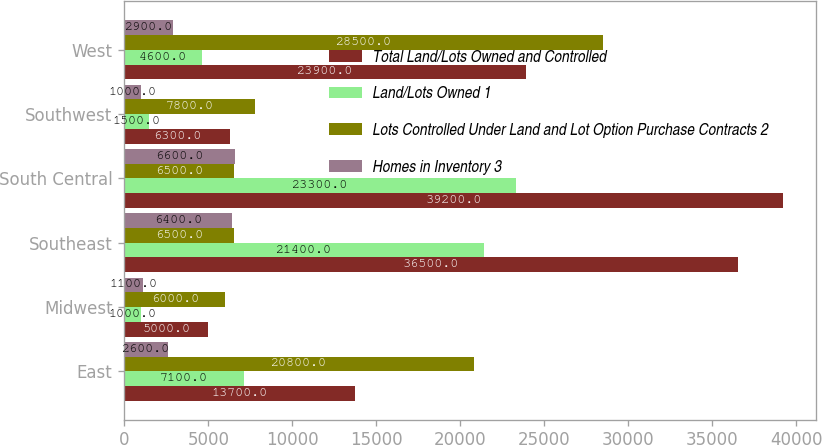Convert chart to OTSL. <chart><loc_0><loc_0><loc_500><loc_500><stacked_bar_chart><ecel><fcel>East<fcel>Midwest<fcel>Southeast<fcel>South Central<fcel>Southwest<fcel>West<nl><fcel>Total Land/Lots Owned and Controlled<fcel>13700<fcel>5000<fcel>36500<fcel>39200<fcel>6300<fcel>23900<nl><fcel>Land/Lots Owned 1<fcel>7100<fcel>1000<fcel>21400<fcel>23300<fcel>1500<fcel>4600<nl><fcel>Lots Controlled Under Land and Lot Option Purchase Contracts 2<fcel>20800<fcel>6000<fcel>6500<fcel>6500<fcel>7800<fcel>28500<nl><fcel>Homes in Inventory 3<fcel>2600<fcel>1100<fcel>6400<fcel>6600<fcel>1000<fcel>2900<nl></chart> 